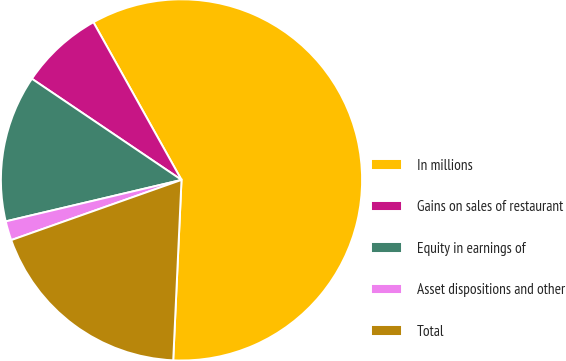Convert chart to OTSL. <chart><loc_0><loc_0><loc_500><loc_500><pie_chart><fcel>In millions<fcel>Gains on sales of restaurant<fcel>Equity in earnings of<fcel>Asset dispositions and other<fcel>Total<nl><fcel>58.84%<fcel>7.43%<fcel>13.15%<fcel>1.72%<fcel>18.86%<nl></chart> 